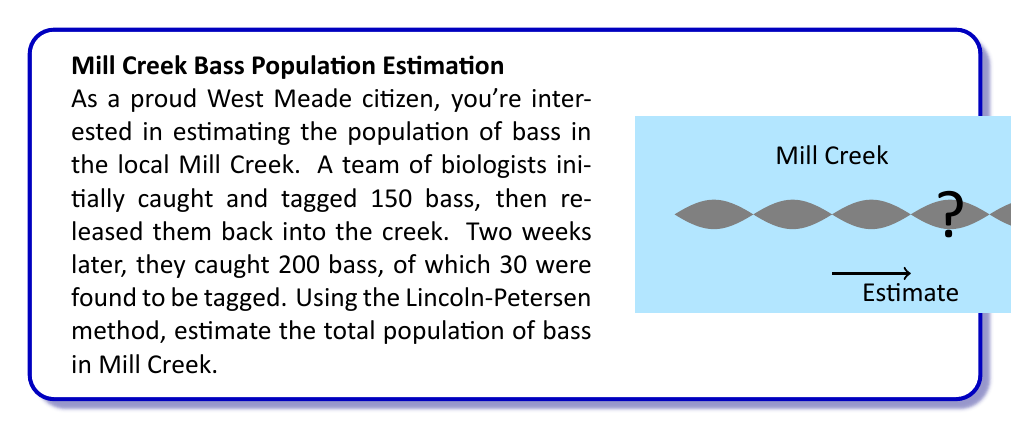Can you answer this question? Let's solve this problem step-by-step using the Lincoln-Petersen method:

1) The Lincoln-Petersen formula for estimating population size is:

   $$N = \frac{MC}{R}$$

   Where:
   $N$ = estimated total population
   $M$ = number of individuals marked on the first visit
   $C$ = total number of individuals captured on the second visit
   $R$ = number of marked individuals recaptured on the second visit

2) From the given information:
   $M = 150$ (initially tagged bass)
   $C = 200$ (bass caught in the second capture)
   $R = 30$ (tagged bass recaptured)

3) Substituting these values into the formula:

   $$N = \frac{150 \times 200}{30}$$

4) Simplifying:
   $$N = \frac{30,000}{30} = 1,000$$

Therefore, the estimated population of bass in Mill Creek is 1,000.

Note: This method assumes a closed population (no births, deaths, immigration, or emigration) and that all fish have an equal chance of being captured.
Answer: 1,000 bass 